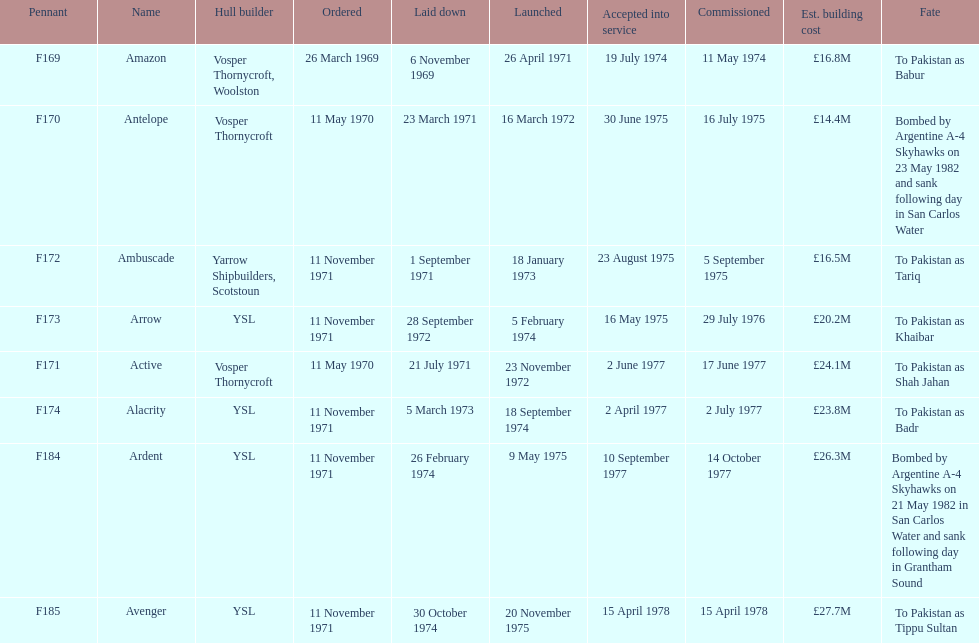Which ship had the highest estimated cost to build? Avenger. 